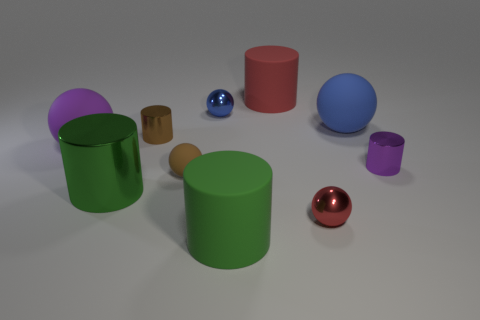What materials do the objects appear to be made of? The materials of the objects vary and include appearances of matte and glossy finishes, suggesting a mix between rubber-like and metallic surfaces. 